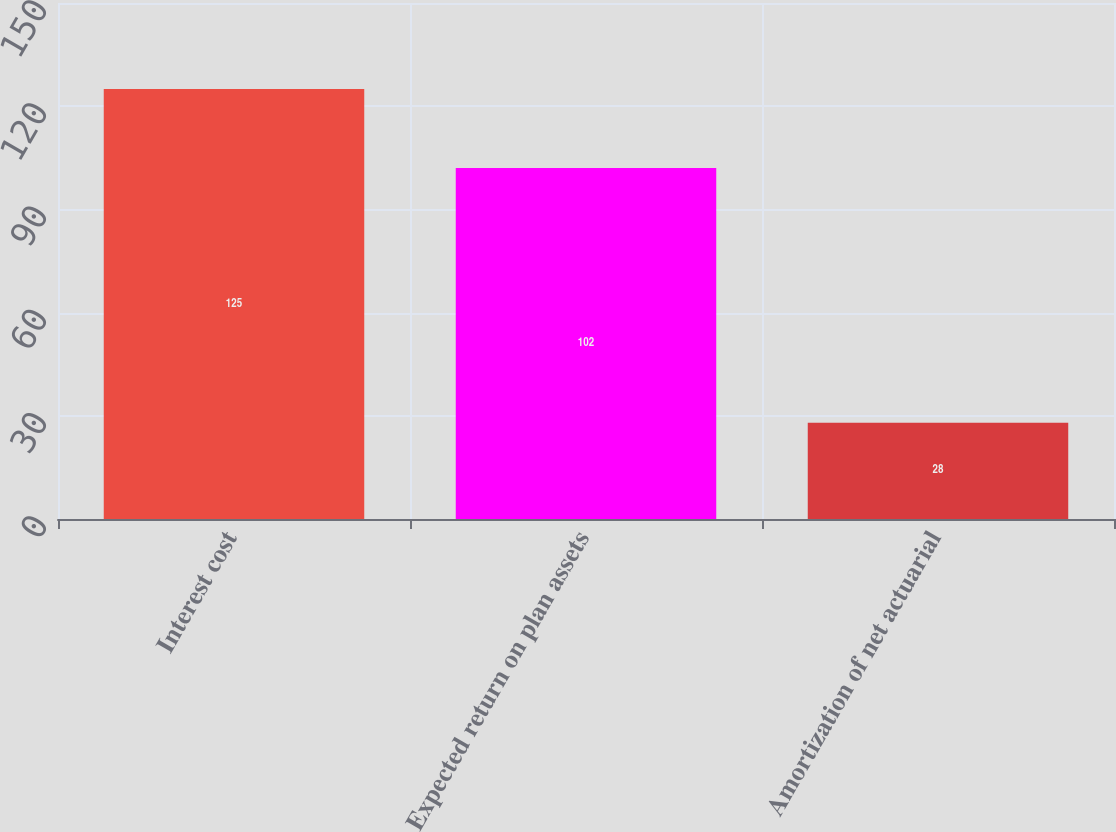Convert chart. <chart><loc_0><loc_0><loc_500><loc_500><bar_chart><fcel>Interest cost<fcel>Expected return on plan assets<fcel>Amortization of net actuarial<nl><fcel>125<fcel>102<fcel>28<nl></chart> 